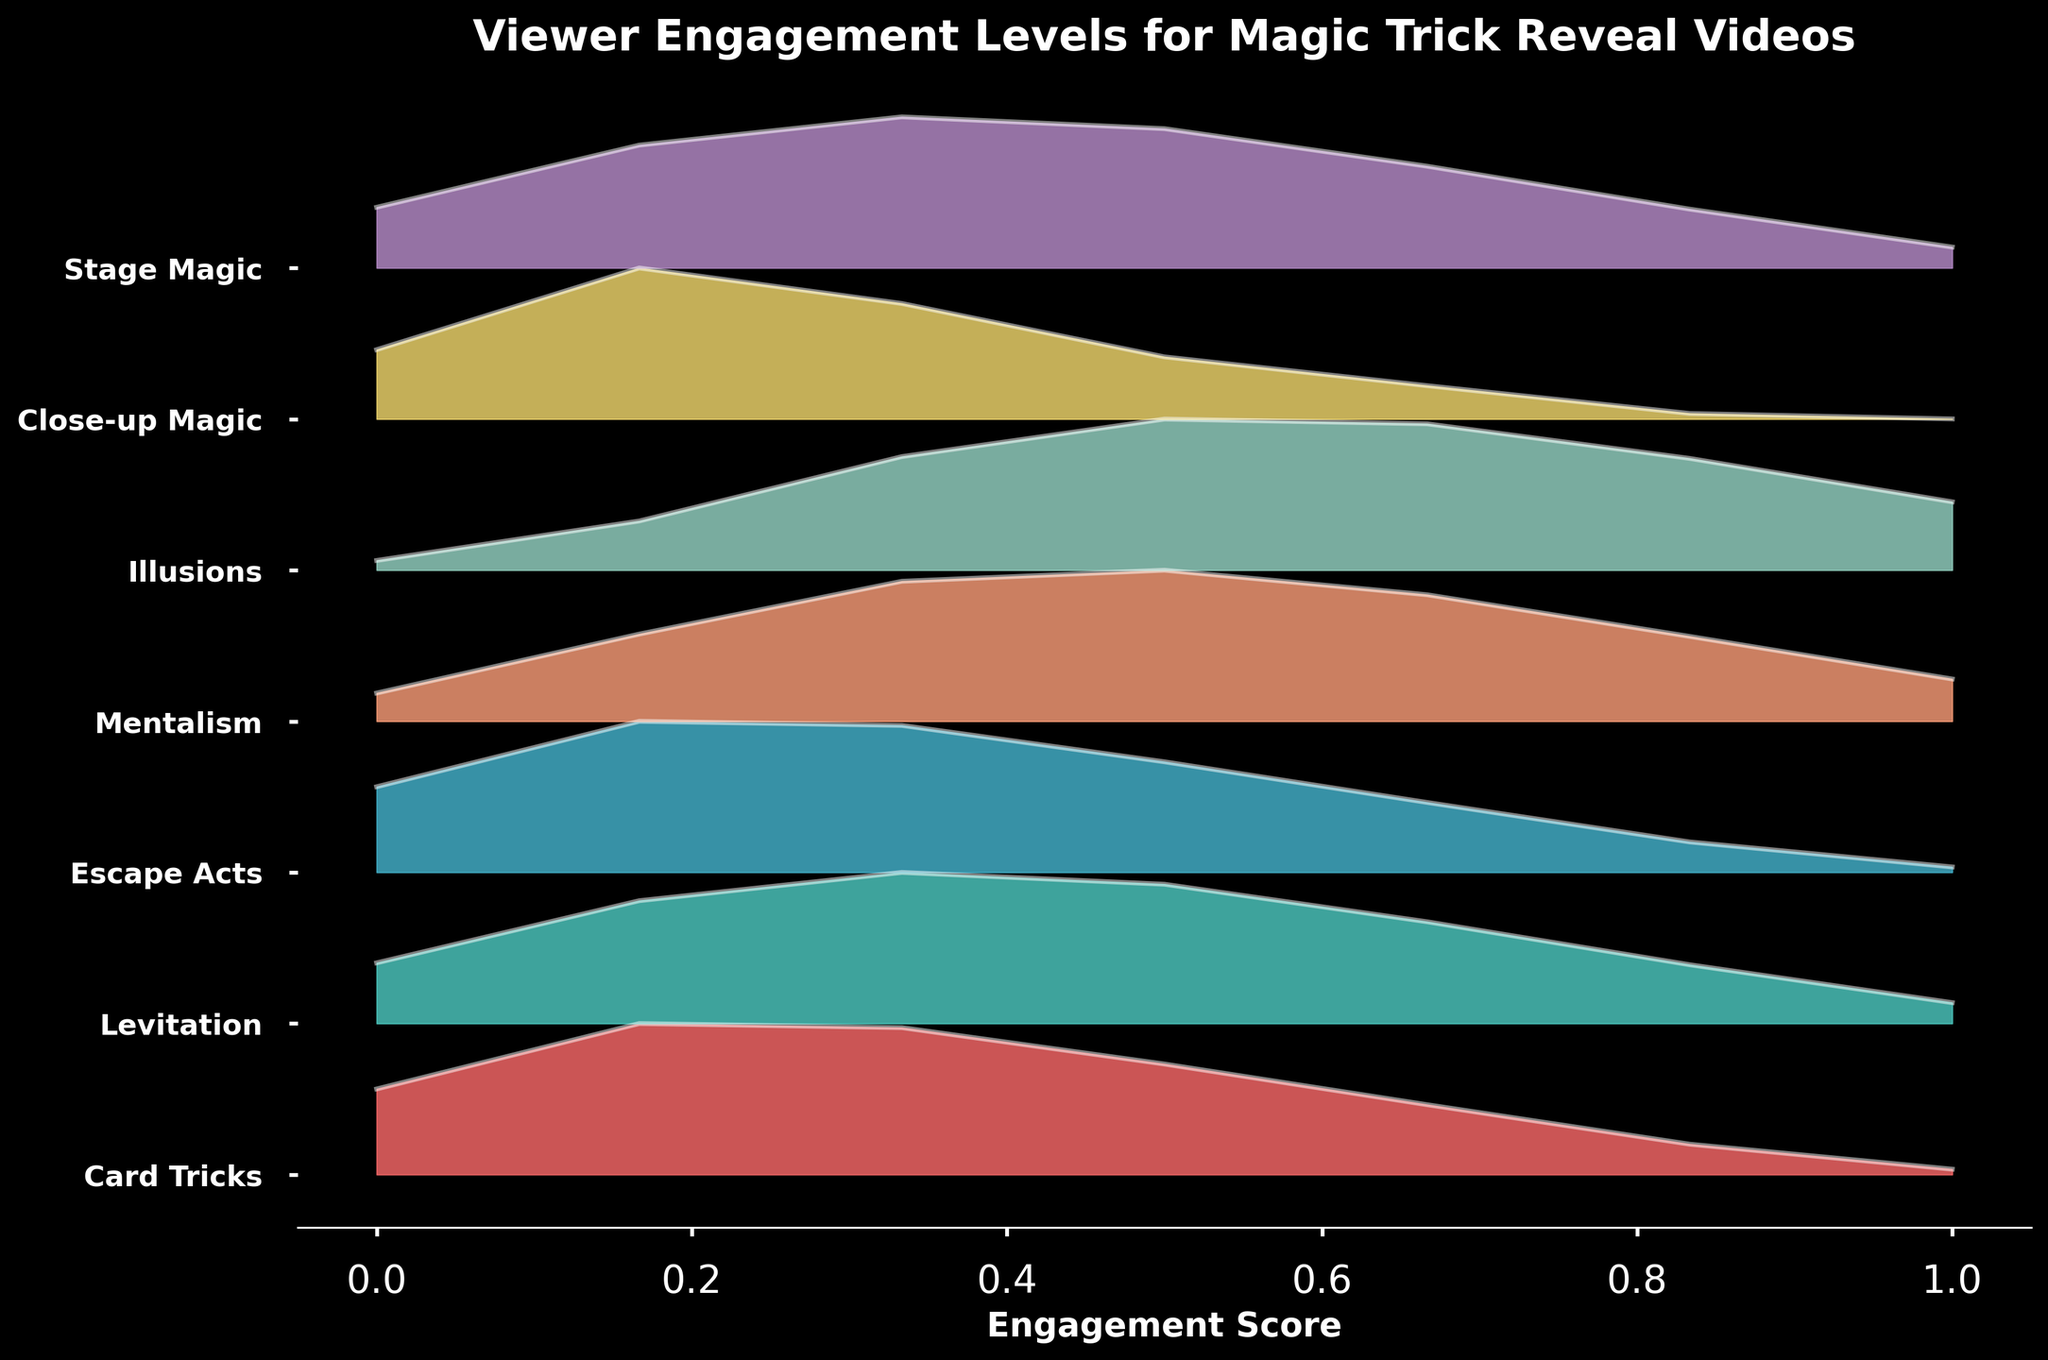what is the title of the figure? The title is written at the top of the figure. It summarizes the content of the plot.
Answer: Viewer Engagement Levels for Magic Trick Reveal Videos What are the y-axis labels? The y-axis labels are the names of the different trick types, which can be read along the vertical axis.
Answer: Card Tricks, Levitation, Escape Acts, Mentalism, Illusions, Close-up Magic, Stage Magic Which trick type has the highest peak in engagement score density? The highest peak corresponds to the segment that reaches the uppermost position on the graph across all trick types.
Answer: Illusions By how many points does the highest engagement score for Mentalism differ from Card Tricks? Identify the highest engagement score for both Mentalism and Card Tricks from the plot and find their difference.
Answer: 0.2 Which two magic tricks have the most similar engagement score distributions? Compare the shapes and positions of the densities of all the trick types to determine which ones are most alike.
Answer: Card Tricks and Escape Acts Considering the Ridgeline plot, which trick type generally has the lowest engagement scores? The trick type with density nearest to the bottom engagement score values consistently can be inferred.
Answer: Close-up Magic How is the viewer engagement score for Levitation compared to Stage Magic? Compare the positions and shapes of the peaks from the two distributions to determine any differences.
Answer: Similar What is the engagement score for the y-axis label at position 4? Identify the trick type at position 4 and find the corresponding engagement score range from the plot.
Answer: Mentalism Order the trick types from highest to lowest peak engagement score density. Arrange the trick types based on the height of their peak density values in descending order.
Answer: Illusions, Mentalism, Levitation, Stage Magic, Escape Acts, Card Tricks, Close-up Magic What can you infer about the viewer engagement trends for magic trick reveal videos? Look at the height and spread of the density peaks to deduce general trends in viewer engagement.
Answer: Illusion and Mentalism tricks generate higher engagement while Close-up Magic tends to have lower engagement 